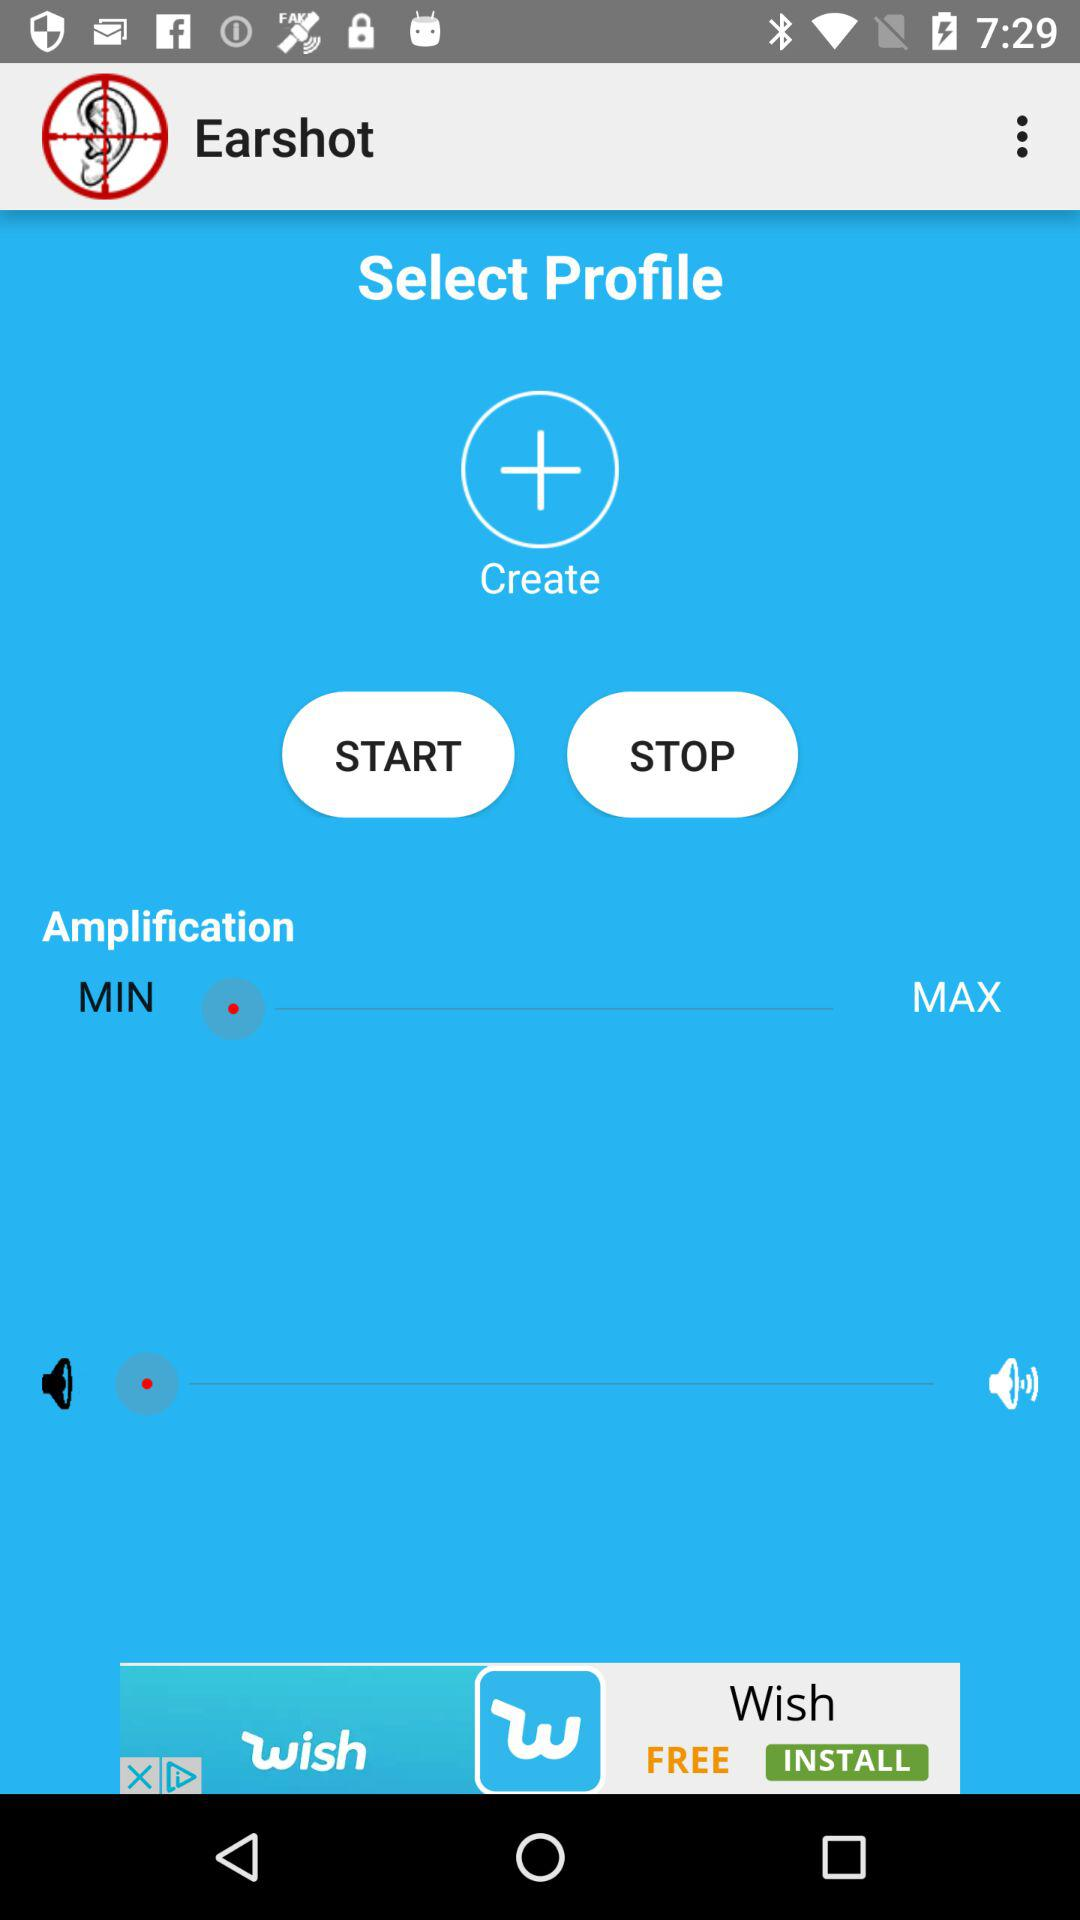What is the current level of amplification? The current level of amplification is minimal. 